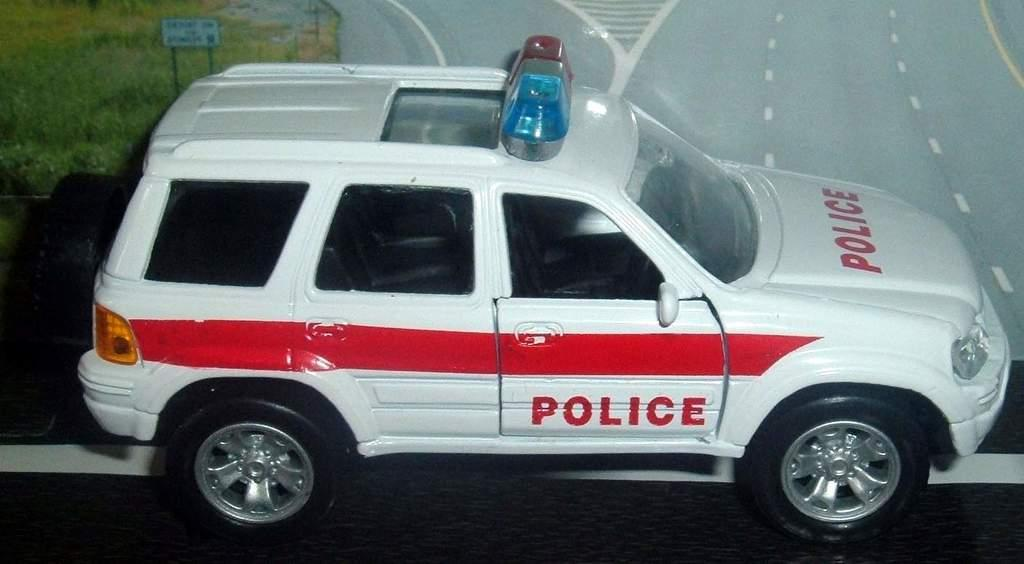What is the main object in the image? There is a car toy in the image. Where is the car toy located? The car toy is on a surface. How many rabbits are playing in the circle of pollution in the image? There are no rabbits or pollution present in the image; it features a car toy on a surface. 